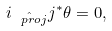<formula> <loc_0><loc_0><loc_500><loc_500>i _ { \hat { \ p r o j } } j ^ { \ast } \theta = 0 ,</formula> 